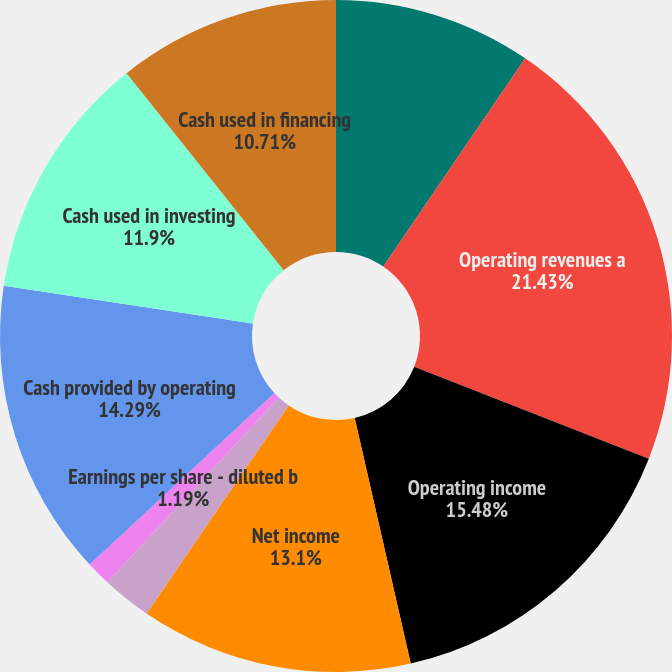Convert chart to OTSL. <chart><loc_0><loc_0><loc_500><loc_500><pie_chart><fcel>Millions Except per Share<fcel>Operating revenues a<fcel>Operating income<fcel>Net income<fcel>Earnings per share - basic b<fcel>Earnings per share - diluted b<fcel>Dividends declared per share b<fcel>Cash provided by operating<fcel>Cash used in investing<fcel>Cash used in financing<nl><fcel>9.52%<fcel>21.43%<fcel>15.48%<fcel>13.1%<fcel>2.38%<fcel>1.19%<fcel>0.0%<fcel>14.29%<fcel>11.9%<fcel>10.71%<nl></chart> 